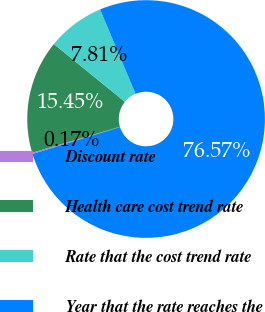Convert chart. <chart><loc_0><loc_0><loc_500><loc_500><pie_chart><fcel>Discount rate<fcel>Health care cost trend rate<fcel>Rate that the cost trend rate<fcel>Year that the rate reaches the<nl><fcel>0.17%<fcel>15.45%<fcel>7.81%<fcel>76.57%<nl></chart> 